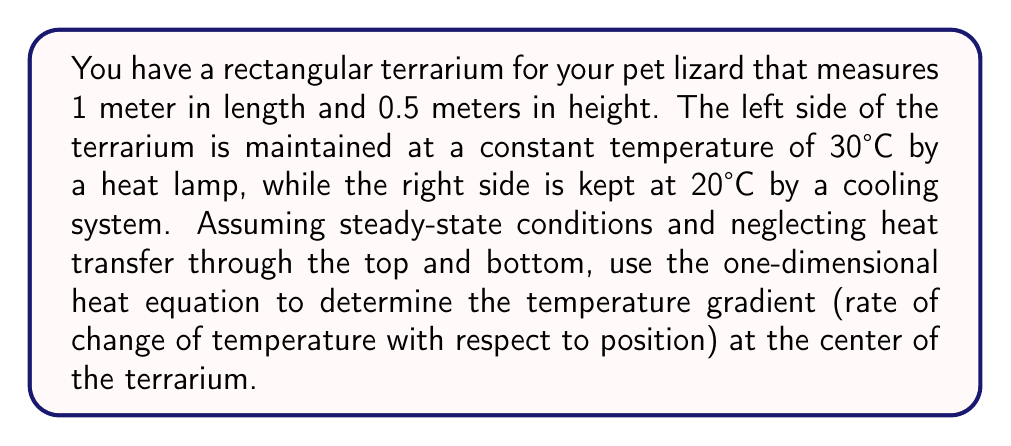Can you answer this question? 1) The one-dimensional steady-state heat equation is:

   $$\frac{d^2T}{dx^2} = 0$$

2) The general solution to this equation is:

   $$T(x) = Ax + B$$

   where A and B are constants to be determined from the boundary conditions.

3) Boundary conditions:
   At x = 0 (left side): T = 30°C
   At x = 1 m (right side): T = 20°C

4) Apply the boundary conditions:
   At x = 0: 30 = B
   At x = 1: 20 = A(1) + B = A + 30

5) Solve for A:
   20 = A + 30
   A = -10

6) Therefore, the temperature distribution is:

   $$T(x) = -10x + 30$$

7) The temperature gradient is the derivative of T(x):

   $$\frac{dT}{dx} = -10$$ °C/m

8) This gradient is constant throughout the terrarium, including at the center.
Answer: -10 °C/m 